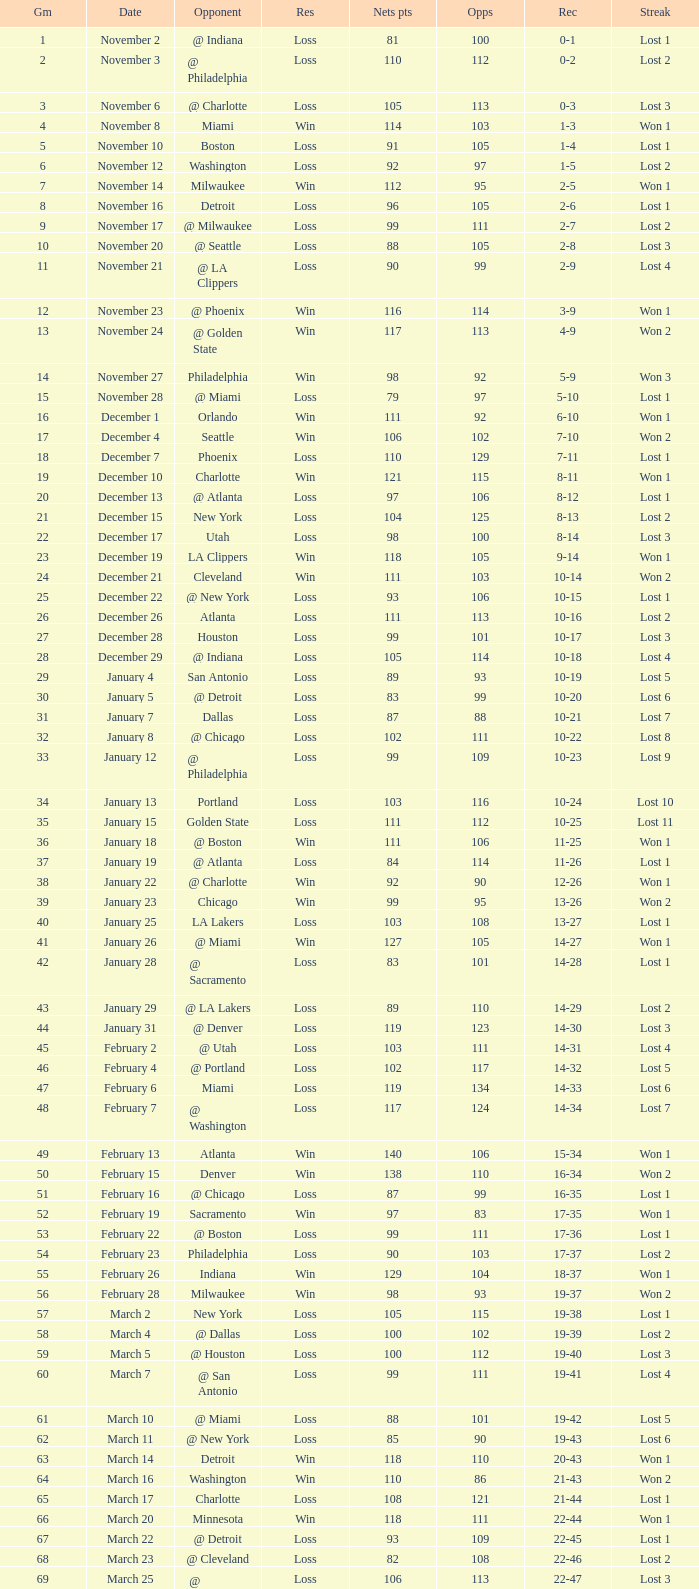Would you mind parsing the complete table? {'header': ['Gm', 'Date', 'Opponent', 'Res', 'Nets pts', 'Opps', 'Rec', 'Streak'], 'rows': [['1', 'November 2', '@ Indiana', 'Loss', '81', '100', '0-1', 'Lost 1'], ['2', 'November 3', '@ Philadelphia', 'Loss', '110', '112', '0-2', 'Lost 2'], ['3', 'November 6', '@ Charlotte', 'Loss', '105', '113', '0-3', 'Lost 3'], ['4', 'November 8', 'Miami', 'Win', '114', '103', '1-3', 'Won 1'], ['5', 'November 10', 'Boston', 'Loss', '91', '105', '1-4', 'Lost 1'], ['6', 'November 12', 'Washington', 'Loss', '92', '97', '1-5', 'Lost 2'], ['7', 'November 14', 'Milwaukee', 'Win', '112', '95', '2-5', 'Won 1'], ['8', 'November 16', 'Detroit', 'Loss', '96', '105', '2-6', 'Lost 1'], ['9', 'November 17', '@ Milwaukee', 'Loss', '99', '111', '2-7', 'Lost 2'], ['10', 'November 20', '@ Seattle', 'Loss', '88', '105', '2-8', 'Lost 3'], ['11', 'November 21', '@ LA Clippers', 'Loss', '90', '99', '2-9', 'Lost 4'], ['12', 'November 23', '@ Phoenix', 'Win', '116', '114', '3-9', 'Won 1'], ['13', 'November 24', '@ Golden State', 'Win', '117', '113', '4-9', 'Won 2'], ['14', 'November 27', 'Philadelphia', 'Win', '98', '92', '5-9', 'Won 3'], ['15', 'November 28', '@ Miami', 'Loss', '79', '97', '5-10', 'Lost 1'], ['16', 'December 1', 'Orlando', 'Win', '111', '92', '6-10', 'Won 1'], ['17', 'December 4', 'Seattle', 'Win', '106', '102', '7-10', 'Won 2'], ['18', 'December 7', 'Phoenix', 'Loss', '110', '129', '7-11', 'Lost 1'], ['19', 'December 10', 'Charlotte', 'Win', '121', '115', '8-11', 'Won 1'], ['20', 'December 13', '@ Atlanta', 'Loss', '97', '106', '8-12', 'Lost 1'], ['21', 'December 15', 'New York', 'Loss', '104', '125', '8-13', 'Lost 2'], ['22', 'December 17', 'Utah', 'Loss', '98', '100', '8-14', 'Lost 3'], ['23', 'December 19', 'LA Clippers', 'Win', '118', '105', '9-14', 'Won 1'], ['24', 'December 21', 'Cleveland', 'Win', '111', '103', '10-14', 'Won 2'], ['25', 'December 22', '@ New York', 'Loss', '93', '106', '10-15', 'Lost 1'], ['26', 'December 26', 'Atlanta', 'Loss', '111', '113', '10-16', 'Lost 2'], ['27', 'December 28', 'Houston', 'Loss', '99', '101', '10-17', 'Lost 3'], ['28', 'December 29', '@ Indiana', 'Loss', '105', '114', '10-18', 'Lost 4'], ['29', 'January 4', 'San Antonio', 'Loss', '89', '93', '10-19', 'Lost 5'], ['30', 'January 5', '@ Detroit', 'Loss', '83', '99', '10-20', 'Lost 6'], ['31', 'January 7', 'Dallas', 'Loss', '87', '88', '10-21', 'Lost 7'], ['32', 'January 8', '@ Chicago', 'Loss', '102', '111', '10-22', 'Lost 8'], ['33', 'January 12', '@ Philadelphia', 'Loss', '99', '109', '10-23', 'Lost 9'], ['34', 'January 13', 'Portland', 'Loss', '103', '116', '10-24', 'Lost 10'], ['35', 'January 15', 'Golden State', 'Loss', '111', '112', '10-25', 'Lost 11'], ['36', 'January 18', '@ Boston', 'Win', '111', '106', '11-25', 'Won 1'], ['37', 'January 19', '@ Atlanta', 'Loss', '84', '114', '11-26', 'Lost 1'], ['38', 'January 22', '@ Charlotte', 'Win', '92', '90', '12-26', 'Won 1'], ['39', 'January 23', 'Chicago', 'Win', '99', '95', '13-26', 'Won 2'], ['40', 'January 25', 'LA Lakers', 'Loss', '103', '108', '13-27', 'Lost 1'], ['41', 'January 26', '@ Miami', 'Win', '127', '105', '14-27', 'Won 1'], ['42', 'January 28', '@ Sacramento', 'Loss', '83', '101', '14-28', 'Lost 1'], ['43', 'January 29', '@ LA Lakers', 'Loss', '89', '110', '14-29', 'Lost 2'], ['44', 'January 31', '@ Denver', 'Loss', '119', '123', '14-30', 'Lost 3'], ['45', 'February 2', '@ Utah', 'Loss', '103', '111', '14-31', 'Lost 4'], ['46', 'February 4', '@ Portland', 'Loss', '102', '117', '14-32', 'Lost 5'], ['47', 'February 6', 'Miami', 'Loss', '119', '134', '14-33', 'Lost 6'], ['48', 'February 7', '@ Washington', 'Loss', '117', '124', '14-34', 'Lost 7'], ['49', 'February 13', 'Atlanta', 'Win', '140', '106', '15-34', 'Won 1'], ['50', 'February 15', 'Denver', 'Win', '138', '110', '16-34', 'Won 2'], ['51', 'February 16', '@ Chicago', 'Loss', '87', '99', '16-35', 'Lost 1'], ['52', 'February 19', 'Sacramento', 'Win', '97', '83', '17-35', 'Won 1'], ['53', 'February 22', '@ Boston', 'Loss', '99', '111', '17-36', 'Lost 1'], ['54', 'February 23', 'Philadelphia', 'Loss', '90', '103', '17-37', 'Lost 2'], ['55', 'February 26', 'Indiana', 'Win', '129', '104', '18-37', 'Won 1'], ['56', 'February 28', 'Milwaukee', 'Win', '98', '93', '19-37', 'Won 2'], ['57', 'March 2', 'New York', 'Loss', '105', '115', '19-38', 'Lost 1'], ['58', 'March 4', '@ Dallas', 'Loss', '100', '102', '19-39', 'Lost 2'], ['59', 'March 5', '@ Houston', 'Loss', '100', '112', '19-40', 'Lost 3'], ['60', 'March 7', '@ San Antonio', 'Loss', '99', '111', '19-41', 'Lost 4'], ['61', 'March 10', '@ Miami', 'Loss', '88', '101', '19-42', 'Lost 5'], ['62', 'March 11', '@ New York', 'Loss', '85', '90', '19-43', 'Lost 6'], ['63', 'March 14', 'Detroit', 'Win', '118', '110', '20-43', 'Won 1'], ['64', 'March 16', 'Washington', 'Win', '110', '86', '21-43', 'Won 2'], ['65', 'March 17', 'Charlotte', 'Loss', '108', '121', '21-44', 'Lost 1'], ['66', 'March 20', 'Minnesota', 'Win', '118', '111', '22-44', 'Won 1'], ['67', 'March 22', '@ Detroit', 'Loss', '93', '109', '22-45', 'Lost 1'], ['68', 'March 23', '@ Cleveland', 'Loss', '82', '108', '22-46', 'Lost 2'], ['69', 'March 25', '@ Washington', 'Loss', '106', '113', '22-47', 'Lost 3'], ['70', 'March 26', 'Philadelphia', 'Win', '98', '95', '23-47', 'Won 1'], ['71', 'March 28', 'Chicago', 'Loss', '94', '128', '23-48', 'Lost 1'], ['72', 'March 30', 'New York', 'Loss', '117', '130', '23-49', 'Lost 2'], ['73', 'April 2', 'Boston', 'Loss', '77', '94', '23-50', 'Lost 3'], ['74', 'April 4', '@ Boston', 'Loss', '104', '123', '23-51', 'Lost 4'], ['75', 'April 6', '@ Milwaukee', 'Loss', '114', '133', '23-52', 'Lost 5'], ['76', 'April 9', '@ Minnesota', 'Loss', '89', '109', '23-53', 'Lost 6'], ['77', 'April 12', 'Cleveland', 'Win', '104', '103', '24-53', 'Won 1'], ['78', 'April 13', '@ Cleveland', 'Loss', '98', '102', '24-54', 'Lost 1'], ['79', 'April 16', 'Indiana', 'Loss', '126', '132', '24-55', 'Lost 2'], ['80', 'April 18', '@ Washington', 'Win', '108', '103', '25-55', 'Won 1'], ['81', 'April 20', 'Miami', 'Win', '118', '103', '26-55', 'Won 2'], ['82', 'April 21', '@ Orlando', 'Loss', '110', '120', '26-56', 'Lost 1']]} In which game did the opponent score more than 103 and the record was 1-3? None. 